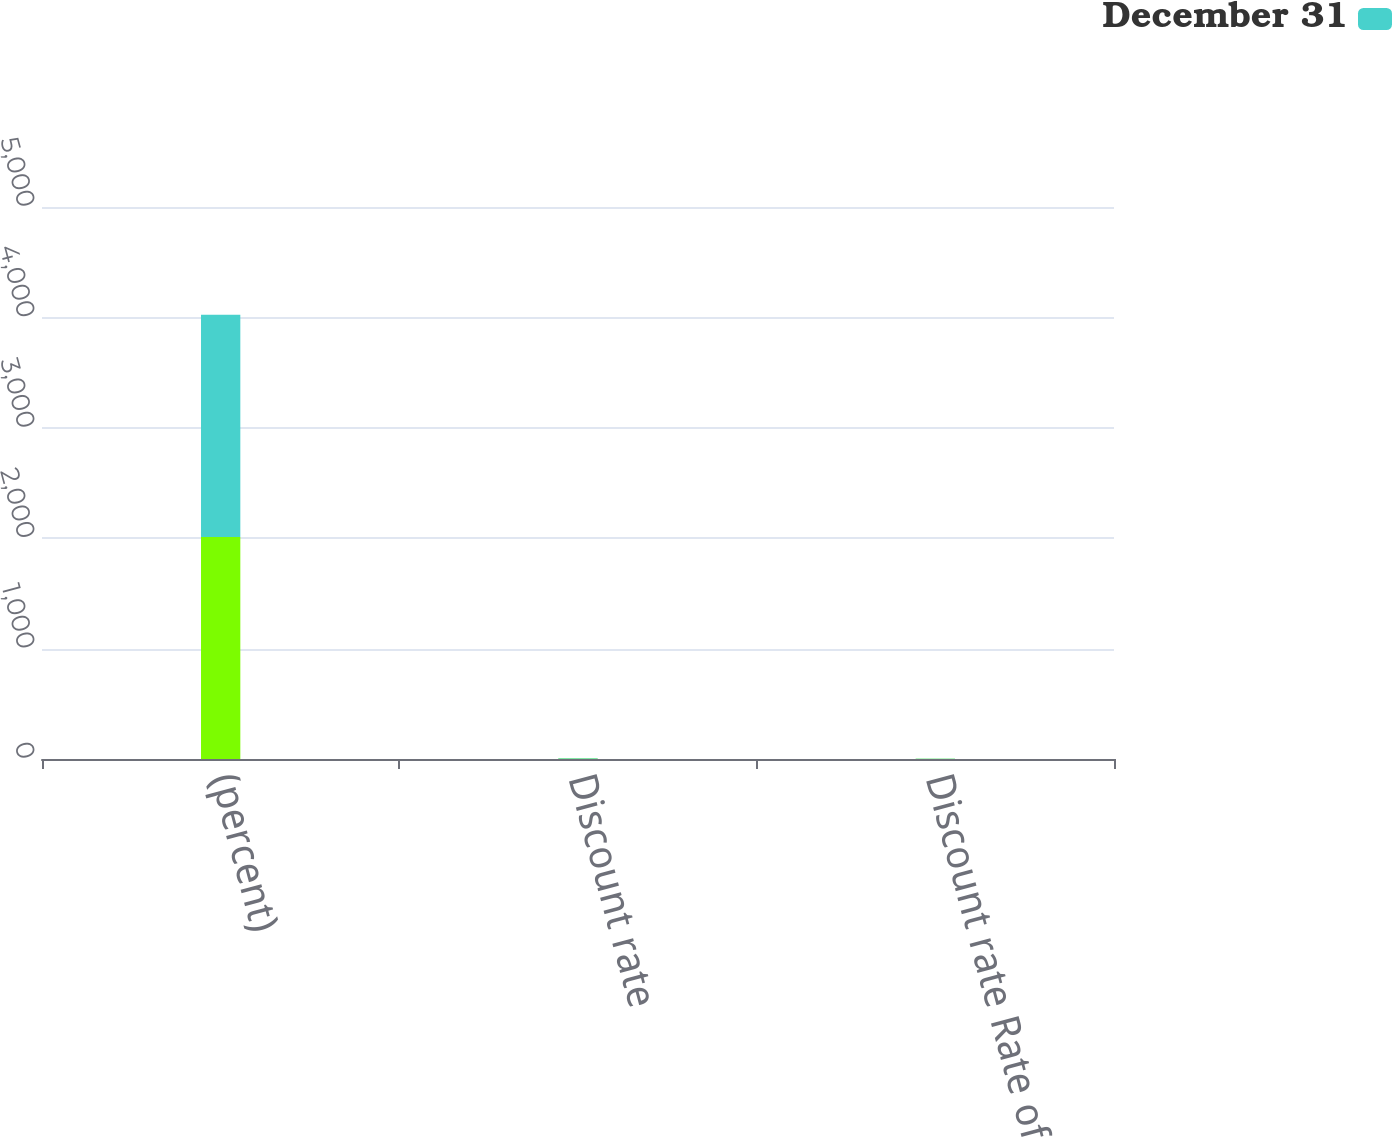<chart> <loc_0><loc_0><loc_500><loc_500><stacked_bar_chart><ecel><fcel>(percent)<fcel>Discount rate<fcel>Discount rate Rate of<nl><fcel>nan<fcel>2012<fcel>3.67<fcel>2.72<nl><fcel>December 31<fcel>2011<fcel>4.42<fcel>2.78<nl></chart> 